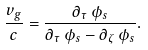<formula> <loc_0><loc_0><loc_500><loc_500>\frac { v _ { g } } c = \frac { \partial _ { \tau } \, \phi _ { s } } { \partial _ { \tau } \, \phi _ { s } - \partial _ { \zeta } \, \phi _ { s } } .</formula> 